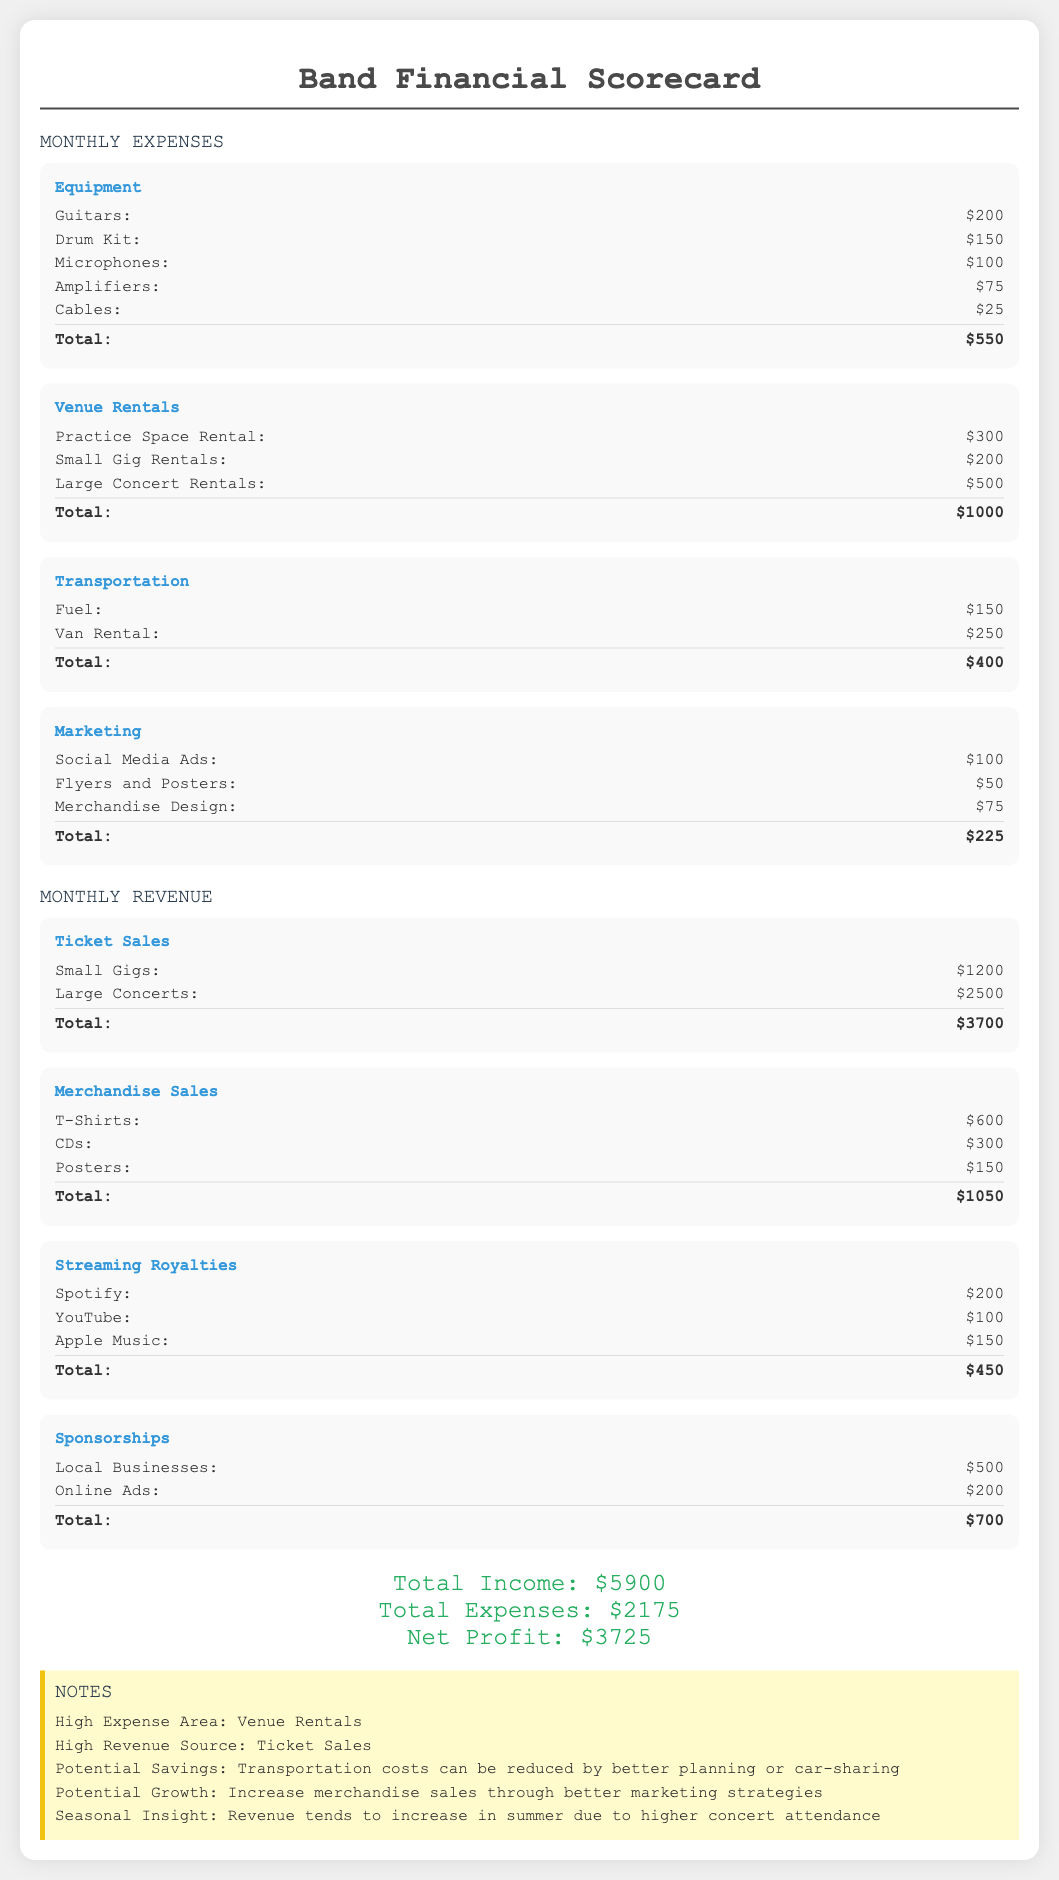what is the total monthly expense? The total monthly expense is the sum of all expenses listed in the document, which is $550 + $1000 + $400 + $225 = $2175.
Answer: $2175 what is the highest revenue source? The highest revenue source is the total from ticket sales, which is $3700 according to the document.
Answer: $3700 what was spent on marketing? The total spent on marketing includes all items listed under that category, which amounts to $225.
Answer: $225 what is the total profit this month? The total profit is calculated by subtracting total expenses from total income, which is $5900 - $2175 = $3725.
Answer: $3725 how much did the band earn from merchandise sales? Merchandise sales total $1050 as shown in the document.
Answer: $1050 what is the expense for venue rentals? Venue rentals total is the sum of all listed venue-related expenses, which is $1000.
Answer: $1000 which area was noted as a high expense? The document mentions that venue rentals are a high expense area.
Answer: Venue Rentals how much did the band earn from streaming royalties? Streaming royalties totaled $450 as detailed in the document.
Answer: $450 what item had the lowest expense in equipment? The lowest expense in the equipment section was for cables, which cost $25.
Answer: $25 